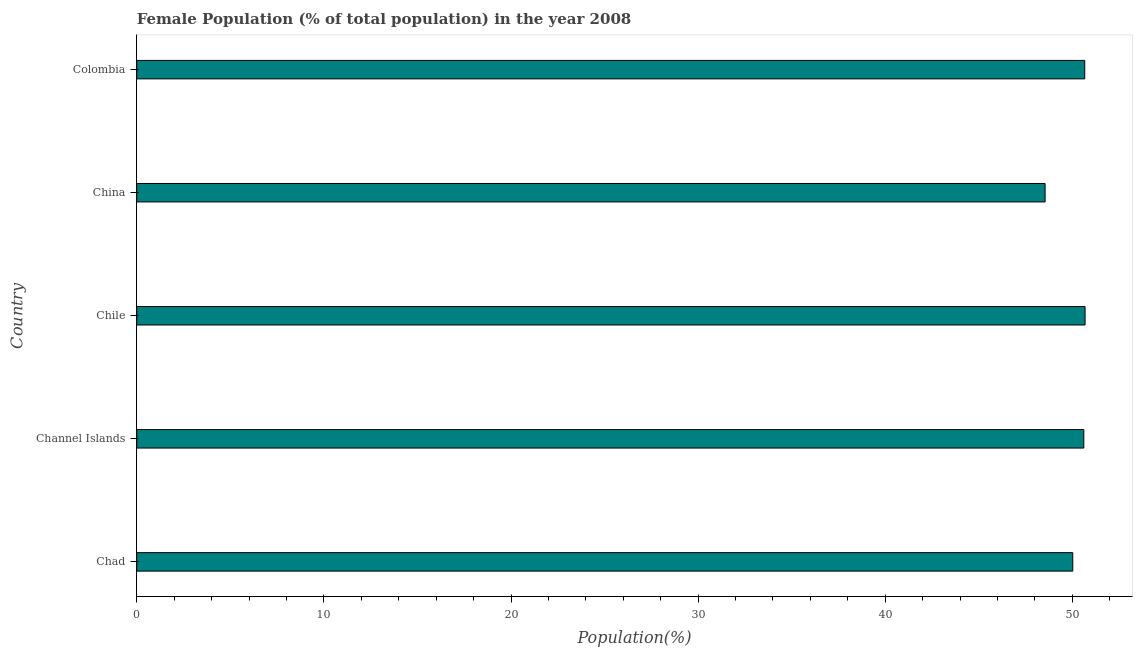What is the title of the graph?
Your answer should be compact. Female Population (% of total population) in the year 2008. What is the label or title of the X-axis?
Give a very brief answer. Population(%). What is the label or title of the Y-axis?
Offer a very short reply. Country. What is the female population in Channel Islands?
Offer a very short reply. 50.61. Across all countries, what is the maximum female population?
Give a very brief answer. 50.68. Across all countries, what is the minimum female population?
Your answer should be very brief. 48.54. What is the sum of the female population?
Your response must be concise. 250.52. What is the difference between the female population in Channel Islands and China?
Give a very brief answer. 2.07. What is the average female population per country?
Your answer should be very brief. 50.1. What is the median female population?
Your answer should be compact. 50.61. In how many countries, is the female population greater than 22 %?
Offer a terse response. 5. Is the difference between the female population in Channel Islands and Chile greater than the difference between any two countries?
Your response must be concise. No. What is the difference between the highest and the second highest female population?
Ensure brevity in your answer.  0.02. What is the difference between the highest and the lowest female population?
Provide a short and direct response. 2.14. In how many countries, is the female population greater than the average female population taken over all countries?
Keep it short and to the point. 3. How many bars are there?
Give a very brief answer. 5. Are the values on the major ticks of X-axis written in scientific E-notation?
Keep it short and to the point. No. What is the Population(%) in Chad?
Your answer should be compact. 50.02. What is the Population(%) of Channel Islands?
Your answer should be very brief. 50.61. What is the Population(%) in Chile?
Your answer should be very brief. 50.68. What is the Population(%) in China?
Make the answer very short. 48.54. What is the Population(%) of Colombia?
Your answer should be very brief. 50.66. What is the difference between the Population(%) in Chad and Channel Islands?
Offer a very short reply. -0.59. What is the difference between the Population(%) in Chad and Chile?
Offer a very short reply. -0.66. What is the difference between the Population(%) in Chad and China?
Provide a succinct answer. 1.48. What is the difference between the Population(%) in Chad and Colombia?
Offer a terse response. -0.64. What is the difference between the Population(%) in Channel Islands and Chile?
Your answer should be very brief. -0.07. What is the difference between the Population(%) in Channel Islands and China?
Give a very brief answer. 2.07. What is the difference between the Population(%) in Channel Islands and Colombia?
Ensure brevity in your answer.  -0.05. What is the difference between the Population(%) in Chile and China?
Provide a succinct answer. 2.14. What is the difference between the Population(%) in Chile and Colombia?
Provide a succinct answer. 0.02. What is the difference between the Population(%) in China and Colombia?
Ensure brevity in your answer.  -2.12. What is the ratio of the Population(%) in Chad to that in Chile?
Your answer should be compact. 0.99. What is the ratio of the Population(%) in Chad to that in China?
Your answer should be compact. 1.03. What is the ratio of the Population(%) in Chad to that in Colombia?
Ensure brevity in your answer.  0.99. What is the ratio of the Population(%) in Channel Islands to that in Chile?
Offer a terse response. 1. What is the ratio of the Population(%) in Channel Islands to that in China?
Offer a terse response. 1.04. What is the ratio of the Population(%) in Channel Islands to that in Colombia?
Provide a short and direct response. 1. What is the ratio of the Population(%) in Chile to that in China?
Your answer should be compact. 1.04. What is the ratio of the Population(%) in China to that in Colombia?
Ensure brevity in your answer.  0.96. 